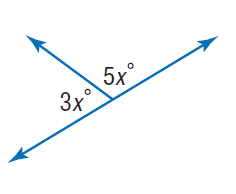Answer the mathemtical geometry problem and directly provide the correct option letter.
Question: Find x.
Choices: A: 22.5 B: 45 C: 60 D: 90 A 